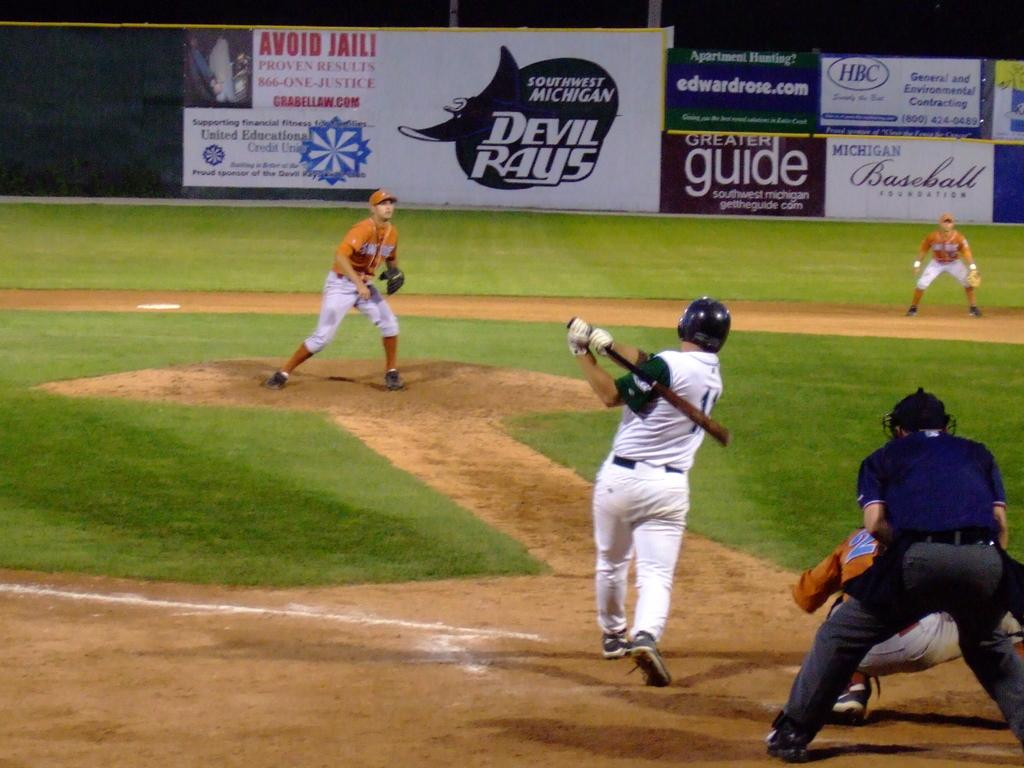Provide a one-sentence caption for the provided image. A man hits a baseball and there are several advertisements in the background, including one for Devil Rays. 